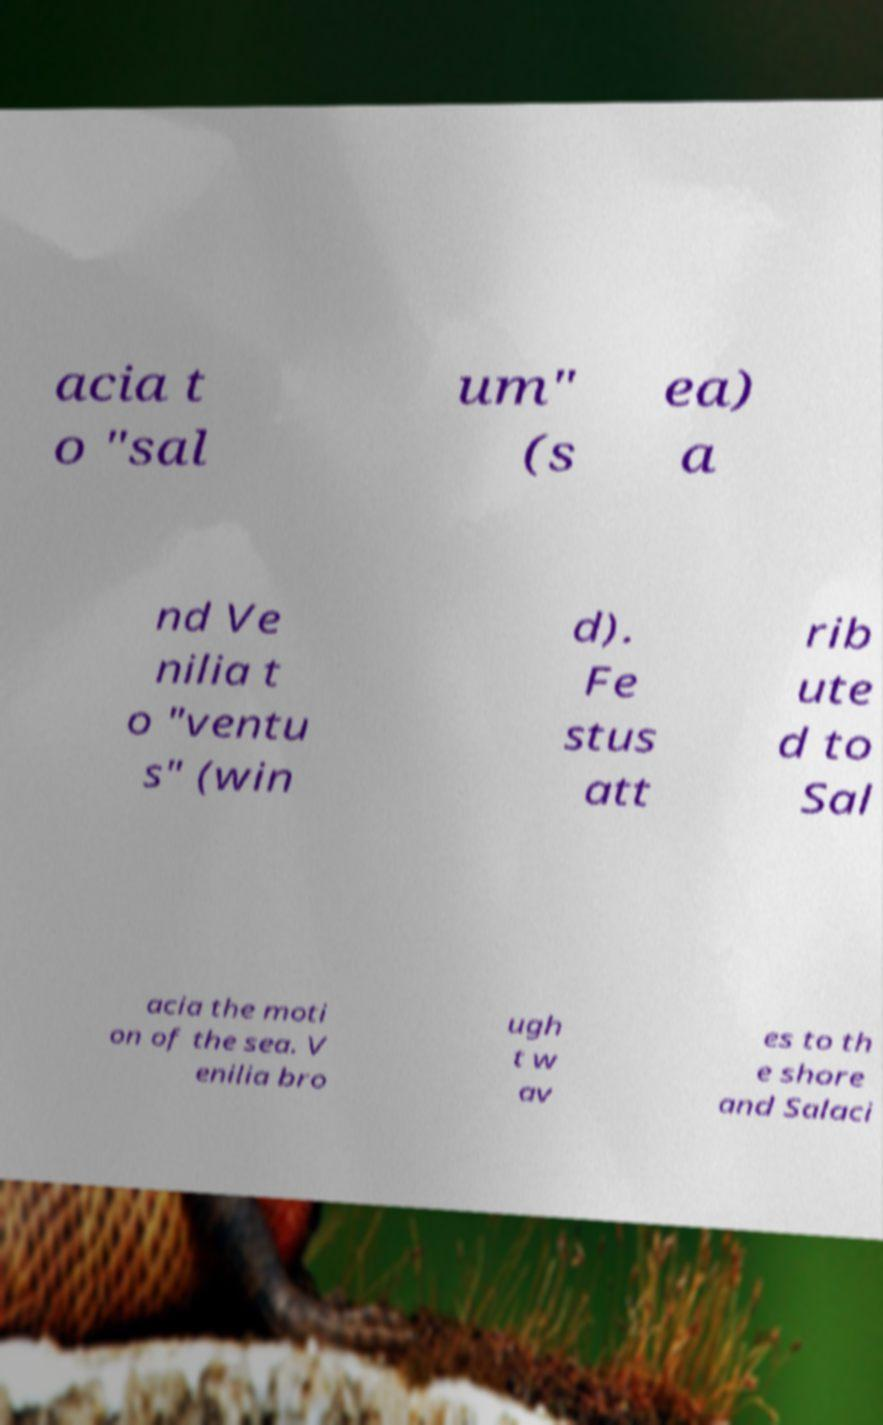Please read and relay the text visible in this image. What does it say? acia t o "sal um" (s ea) a nd Ve nilia t o "ventu s" (win d). Fe stus att rib ute d to Sal acia the moti on of the sea. V enilia bro ugh t w av es to th e shore and Salaci 